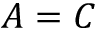<formula> <loc_0><loc_0><loc_500><loc_500>A = C</formula> 